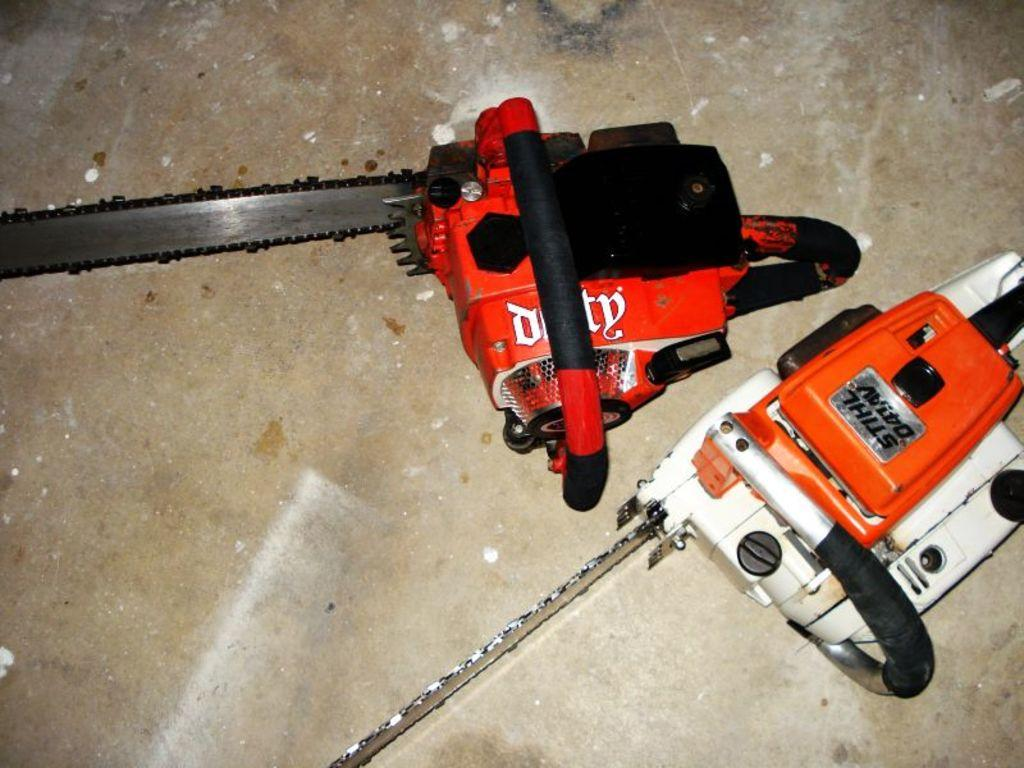What is placed on the floor in the image? There are objects placed on the floor. Can you describe the objects on the floor? Unfortunately, the facts provided do not specify the type of objects on the floor. Are there any people visible in the image? The facts provided do not mention any people in the image. What type of apparel is the parent wearing at the zoo in the image? There is no parent, zoo, or apparel present in the image. The image only shows objects placed on the floor. 